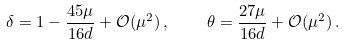Convert formula to latex. <formula><loc_0><loc_0><loc_500><loc_500>\delta = 1 - \frac { 4 5 \mu } { 1 6 d } + \mathcal { O } ( \mu ^ { 2 } ) \, , \quad \theta = \frac { 2 7 \mu } { 1 6 d } + \mathcal { O } ( \mu ^ { 2 } ) \, .</formula> 